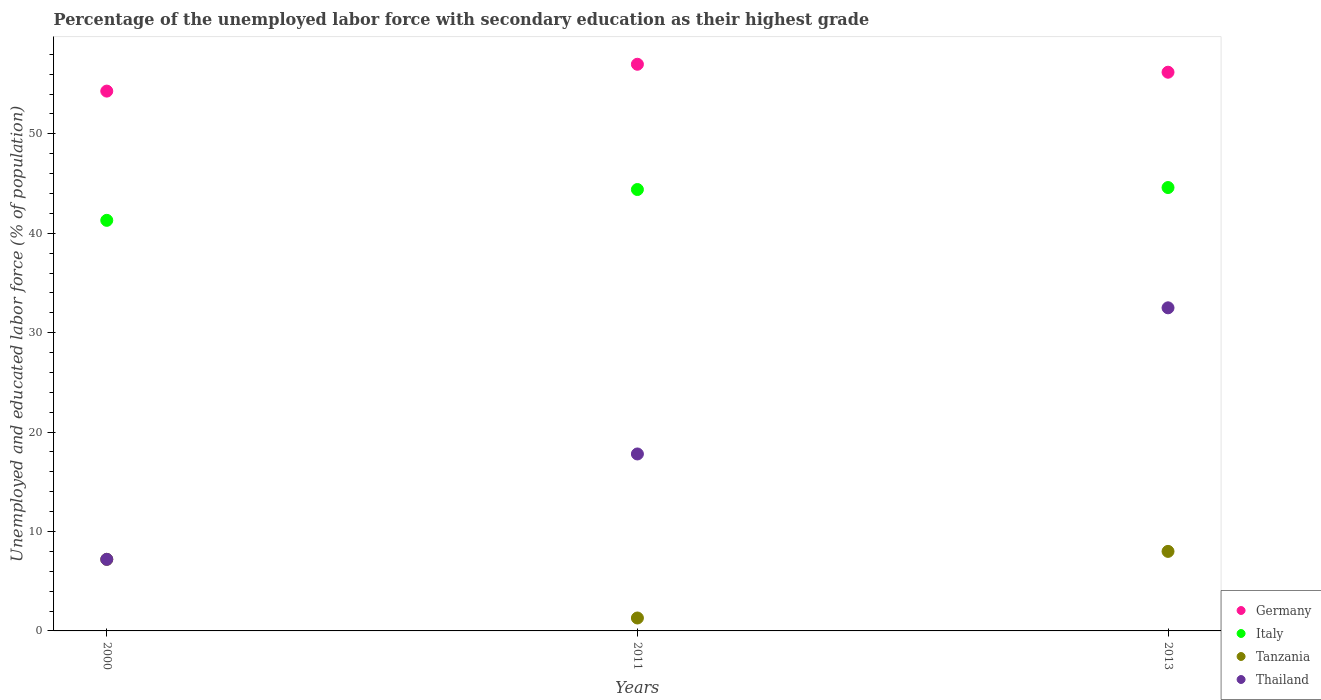How many different coloured dotlines are there?
Provide a short and direct response. 4. Is the number of dotlines equal to the number of legend labels?
Provide a succinct answer. Yes. What is the percentage of the unemployed labor force with secondary education in Italy in 2000?
Provide a short and direct response. 41.3. Across all years, what is the maximum percentage of the unemployed labor force with secondary education in Germany?
Your answer should be very brief. 57. Across all years, what is the minimum percentage of the unemployed labor force with secondary education in Germany?
Offer a very short reply. 54.3. In which year was the percentage of the unemployed labor force with secondary education in Thailand maximum?
Provide a short and direct response. 2013. What is the total percentage of the unemployed labor force with secondary education in Thailand in the graph?
Ensure brevity in your answer.  57.5. What is the difference between the percentage of the unemployed labor force with secondary education in Germany in 2000 and that in 2013?
Offer a terse response. -1.9. What is the difference between the percentage of the unemployed labor force with secondary education in Tanzania in 2011 and the percentage of the unemployed labor force with secondary education in Germany in 2000?
Your answer should be very brief. -53. What is the average percentage of the unemployed labor force with secondary education in Germany per year?
Make the answer very short. 55.83. In the year 2013, what is the difference between the percentage of the unemployed labor force with secondary education in Tanzania and percentage of the unemployed labor force with secondary education in Italy?
Provide a succinct answer. -36.6. In how many years, is the percentage of the unemployed labor force with secondary education in Italy greater than 56 %?
Ensure brevity in your answer.  0. What is the ratio of the percentage of the unemployed labor force with secondary education in Tanzania in 2000 to that in 2013?
Offer a terse response. 0.9. Is the percentage of the unemployed labor force with secondary education in Tanzania in 2000 less than that in 2011?
Offer a terse response. No. Is the difference between the percentage of the unemployed labor force with secondary education in Tanzania in 2000 and 2013 greater than the difference between the percentage of the unemployed labor force with secondary education in Italy in 2000 and 2013?
Offer a very short reply. Yes. What is the difference between the highest and the second highest percentage of the unemployed labor force with secondary education in Germany?
Your answer should be compact. 0.8. What is the difference between the highest and the lowest percentage of the unemployed labor force with secondary education in Thailand?
Keep it short and to the point. 25.3. In how many years, is the percentage of the unemployed labor force with secondary education in Tanzania greater than the average percentage of the unemployed labor force with secondary education in Tanzania taken over all years?
Offer a very short reply. 2. Is it the case that in every year, the sum of the percentage of the unemployed labor force with secondary education in Thailand and percentage of the unemployed labor force with secondary education in Tanzania  is greater than the percentage of the unemployed labor force with secondary education in Italy?
Your response must be concise. No. Does the percentage of the unemployed labor force with secondary education in Thailand monotonically increase over the years?
Give a very brief answer. Yes. Is the percentage of the unemployed labor force with secondary education in Germany strictly greater than the percentage of the unemployed labor force with secondary education in Italy over the years?
Your response must be concise. Yes. Is the percentage of the unemployed labor force with secondary education in Germany strictly less than the percentage of the unemployed labor force with secondary education in Italy over the years?
Provide a succinct answer. No. Are the values on the major ticks of Y-axis written in scientific E-notation?
Offer a terse response. No. Does the graph contain any zero values?
Make the answer very short. No. Where does the legend appear in the graph?
Ensure brevity in your answer.  Bottom right. How many legend labels are there?
Provide a short and direct response. 4. How are the legend labels stacked?
Offer a terse response. Vertical. What is the title of the graph?
Your answer should be very brief. Percentage of the unemployed labor force with secondary education as their highest grade. Does "Turkmenistan" appear as one of the legend labels in the graph?
Provide a succinct answer. No. What is the label or title of the Y-axis?
Provide a succinct answer. Unemployed and educated labor force (% of population). What is the Unemployed and educated labor force (% of population) in Germany in 2000?
Offer a very short reply. 54.3. What is the Unemployed and educated labor force (% of population) in Italy in 2000?
Your answer should be compact. 41.3. What is the Unemployed and educated labor force (% of population) in Tanzania in 2000?
Your response must be concise. 7.2. What is the Unemployed and educated labor force (% of population) of Thailand in 2000?
Offer a very short reply. 7.2. What is the Unemployed and educated labor force (% of population) in Germany in 2011?
Your response must be concise. 57. What is the Unemployed and educated labor force (% of population) in Italy in 2011?
Offer a terse response. 44.4. What is the Unemployed and educated labor force (% of population) in Tanzania in 2011?
Provide a short and direct response. 1.3. What is the Unemployed and educated labor force (% of population) of Thailand in 2011?
Give a very brief answer. 17.8. What is the Unemployed and educated labor force (% of population) in Germany in 2013?
Keep it short and to the point. 56.2. What is the Unemployed and educated labor force (% of population) in Italy in 2013?
Ensure brevity in your answer.  44.6. What is the Unemployed and educated labor force (% of population) of Thailand in 2013?
Your answer should be compact. 32.5. Across all years, what is the maximum Unemployed and educated labor force (% of population) in Germany?
Your answer should be very brief. 57. Across all years, what is the maximum Unemployed and educated labor force (% of population) of Italy?
Make the answer very short. 44.6. Across all years, what is the maximum Unemployed and educated labor force (% of population) in Tanzania?
Make the answer very short. 8. Across all years, what is the maximum Unemployed and educated labor force (% of population) in Thailand?
Ensure brevity in your answer.  32.5. Across all years, what is the minimum Unemployed and educated labor force (% of population) of Germany?
Keep it short and to the point. 54.3. Across all years, what is the minimum Unemployed and educated labor force (% of population) of Italy?
Offer a terse response. 41.3. Across all years, what is the minimum Unemployed and educated labor force (% of population) of Tanzania?
Make the answer very short. 1.3. Across all years, what is the minimum Unemployed and educated labor force (% of population) in Thailand?
Keep it short and to the point. 7.2. What is the total Unemployed and educated labor force (% of population) of Germany in the graph?
Your response must be concise. 167.5. What is the total Unemployed and educated labor force (% of population) of Italy in the graph?
Provide a succinct answer. 130.3. What is the total Unemployed and educated labor force (% of population) in Thailand in the graph?
Provide a succinct answer. 57.5. What is the difference between the Unemployed and educated labor force (% of population) of Tanzania in 2000 and that in 2011?
Your response must be concise. 5.9. What is the difference between the Unemployed and educated labor force (% of population) in Thailand in 2000 and that in 2011?
Make the answer very short. -10.6. What is the difference between the Unemployed and educated labor force (% of population) in Germany in 2000 and that in 2013?
Your response must be concise. -1.9. What is the difference between the Unemployed and educated labor force (% of population) in Italy in 2000 and that in 2013?
Give a very brief answer. -3.3. What is the difference between the Unemployed and educated labor force (% of population) of Thailand in 2000 and that in 2013?
Provide a succinct answer. -25.3. What is the difference between the Unemployed and educated labor force (% of population) of Germany in 2011 and that in 2013?
Offer a very short reply. 0.8. What is the difference between the Unemployed and educated labor force (% of population) in Thailand in 2011 and that in 2013?
Ensure brevity in your answer.  -14.7. What is the difference between the Unemployed and educated labor force (% of population) of Germany in 2000 and the Unemployed and educated labor force (% of population) of Italy in 2011?
Provide a short and direct response. 9.9. What is the difference between the Unemployed and educated labor force (% of population) in Germany in 2000 and the Unemployed and educated labor force (% of population) in Thailand in 2011?
Your answer should be very brief. 36.5. What is the difference between the Unemployed and educated labor force (% of population) of Italy in 2000 and the Unemployed and educated labor force (% of population) of Thailand in 2011?
Provide a succinct answer. 23.5. What is the difference between the Unemployed and educated labor force (% of population) of Tanzania in 2000 and the Unemployed and educated labor force (% of population) of Thailand in 2011?
Make the answer very short. -10.6. What is the difference between the Unemployed and educated labor force (% of population) of Germany in 2000 and the Unemployed and educated labor force (% of population) of Tanzania in 2013?
Your answer should be compact. 46.3. What is the difference between the Unemployed and educated labor force (% of population) in Germany in 2000 and the Unemployed and educated labor force (% of population) in Thailand in 2013?
Make the answer very short. 21.8. What is the difference between the Unemployed and educated labor force (% of population) of Italy in 2000 and the Unemployed and educated labor force (% of population) of Tanzania in 2013?
Ensure brevity in your answer.  33.3. What is the difference between the Unemployed and educated labor force (% of population) in Italy in 2000 and the Unemployed and educated labor force (% of population) in Thailand in 2013?
Make the answer very short. 8.8. What is the difference between the Unemployed and educated labor force (% of population) of Tanzania in 2000 and the Unemployed and educated labor force (% of population) of Thailand in 2013?
Offer a very short reply. -25.3. What is the difference between the Unemployed and educated labor force (% of population) of Italy in 2011 and the Unemployed and educated labor force (% of population) of Tanzania in 2013?
Your answer should be very brief. 36.4. What is the difference between the Unemployed and educated labor force (% of population) of Tanzania in 2011 and the Unemployed and educated labor force (% of population) of Thailand in 2013?
Provide a short and direct response. -31.2. What is the average Unemployed and educated labor force (% of population) of Germany per year?
Offer a terse response. 55.83. What is the average Unemployed and educated labor force (% of population) of Italy per year?
Provide a short and direct response. 43.43. What is the average Unemployed and educated labor force (% of population) in Thailand per year?
Provide a short and direct response. 19.17. In the year 2000, what is the difference between the Unemployed and educated labor force (% of population) of Germany and Unemployed and educated labor force (% of population) of Tanzania?
Provide a succinct answer. 47.1. In the year 2000, what is the difference between the Unemployed and educated labor force (% of population) in Germany and Unemployed and educated labor force (% of population) in Thailand?
Give a very brief answer. 47.1. In the year 2000, what is the difference between the Unemployed and educated labor force (% of population) of Italy and Unemployed and educated labor force (% of population) of Tanzania?
Keep it short and to the point. 34.1. In the year 2000, what is the difference between the Unemployed and educated labor force (% of population) of Italy and Unemployed and educated labor force (% of population) of Thailand?
Make the answer very short. 34.1. In the year 2011, what is the difference between the Unemployed and educated labor force (% of population) of Germany and Unemployed and educated labor force (% of population) of Italy?
Provide a succinct answer. 12.6. In the year 2011, what is the difference between the Unemployed and educated labor force (% of population) of Germany and Unemployed and educated labor force (% of population) of Tanzania?
Offer a terse response. 55.7. In the year 2011, what is the difference between the Unemployed and educated labor force (% of population) in Germany and Unemployed and educated labor force (% of population) in Thailand?
Provide a succinct answer. 39.2. In the year 2011, what is the difference between the Unemployed and educated labor force (% of population) of Italy and Unemployed and educated labor force (% of population) of Tanzania?
Your answer should be very brief. 43.1. In the year 2011, what is the difference between the Unemployed and educated labor force (% of population) in Italy and Unemployed and educated labor force (% of population) in Thailand?
Provide a short and direct response. 26.6. In the year 2011, what is the difference between the Unemployed and educated labor force (% of population) in Tanzania and Unemployed and educated labor force (% of population) in Thailand?
Your answer should be very brief. -16.5. In the year 2013, what is the difference between the Unemployed and educated labor force (% of population) of Germany and Unemployed and educated labor force (% of population) of Italy?
Provide a succinct answer. 11.6. In the year 2013, what is the difference between the Unemployed and educated labor force (% of population) of Germany and Unemployed and educated labor force (% of population) of Tanzania?
Keep it short and to the point. 48.2. In the year 2013, what is the difference between the Unemployed and educated labor force (% of population) of Germany and Unemployed and educated labor force (% of population) of Thailand?
Ensure brevity in your answer.  23.7. In the year 2013, what is the difference between the Unemployed and educated labor force (% of population) of Italy and Unemployed and educated labor force (% of population) of Tanzania?
Provide a short and direct response. 36.6. In the year 2013, what is the difference between the Unemployed and educated labor force (% of population) of Tanzania and Unemployed and educated labor force (% of population) of Thailand?
Provide a short and direct response. -24.5. What is the ratio of the Unemployed and educated labor force (% of population) of Germany in 2000 to that in 2011?
Offer a terse response. 0.95. What is the ratio of the Unemployed and educated labor force (% of population) in Italy in 2000 to that in 2011?
Your response must be concise. 0.93. What is the ratio of the Unemployed and educated labor force (% of population) in Tanzania in 2000 to that in 2011?
Offer a terse response. 5.54. What is the ratio of the Unemployed and educated labor force (% of population) in Thailand in 2000 to that in 2011?
Provide a short and direct response. 0.4. What is the ratio of the Unemployed and educated labor force (% of population) in Germany in 2000 to that in 2013?
Provide a short and direct response. 0.97. What is the ratio of the Unemployed and educated labor force (% of population) in Italy in 2000 to that in 2013?
Offer a very short reply. 0.93. What is the ratio of the Unemployed and educated labor force (% of population) in Tanzania in 2000 to that in 2013?
Your answer should be compact. 0.9. What is the ratio of the Unemployed and educated labor force (% of population) in Thailand in 2000 to that in 2013?
Your answer should be compact. 0.22. What is the ratio of the Unemployed and educated labor force (% of population) of Germany in 2011 to that in 2013?
Your answer should be compact. 1.01. What is the ratio of the Unemployed and educated labor force (% of population) of Italy in 2011 to that in 2013?
Offer a very short reply. 1. What is the ratio of the Unemployed and educated labor force (% of population) of Tanzania in 2011 to that in 2013?
Give a very brief answer. 0.16. What is the ratio of the Unemployed and educated labor force (% of population) in Thailand in 2011 to that in 2013?
Give a very brief answer. 0.55. What is the difference between the highest and the second highest Unemployed and educated labor force (% of population) in Germany?
Make the answer very short. 0.8. What is the difference between the highest and the second highest Unemployed and educated labor force (% of population) of Tanzania?
Provide a short and direct response. 0.8. What is the difference between the highest and the second highest Unemployed and educated labor force (% of population) of Thailand?
Your answer should be very brief. 14.7. What is the difference between the highest and the lowest Unemployed and educated labor force (% of population) of Italy?
Your answer should be very brief. 3.3. What is the difference between the highest and the lowest Unemployed and educated labor force (% of population) of Thailand?
Give a very brief answer. 25.3. 